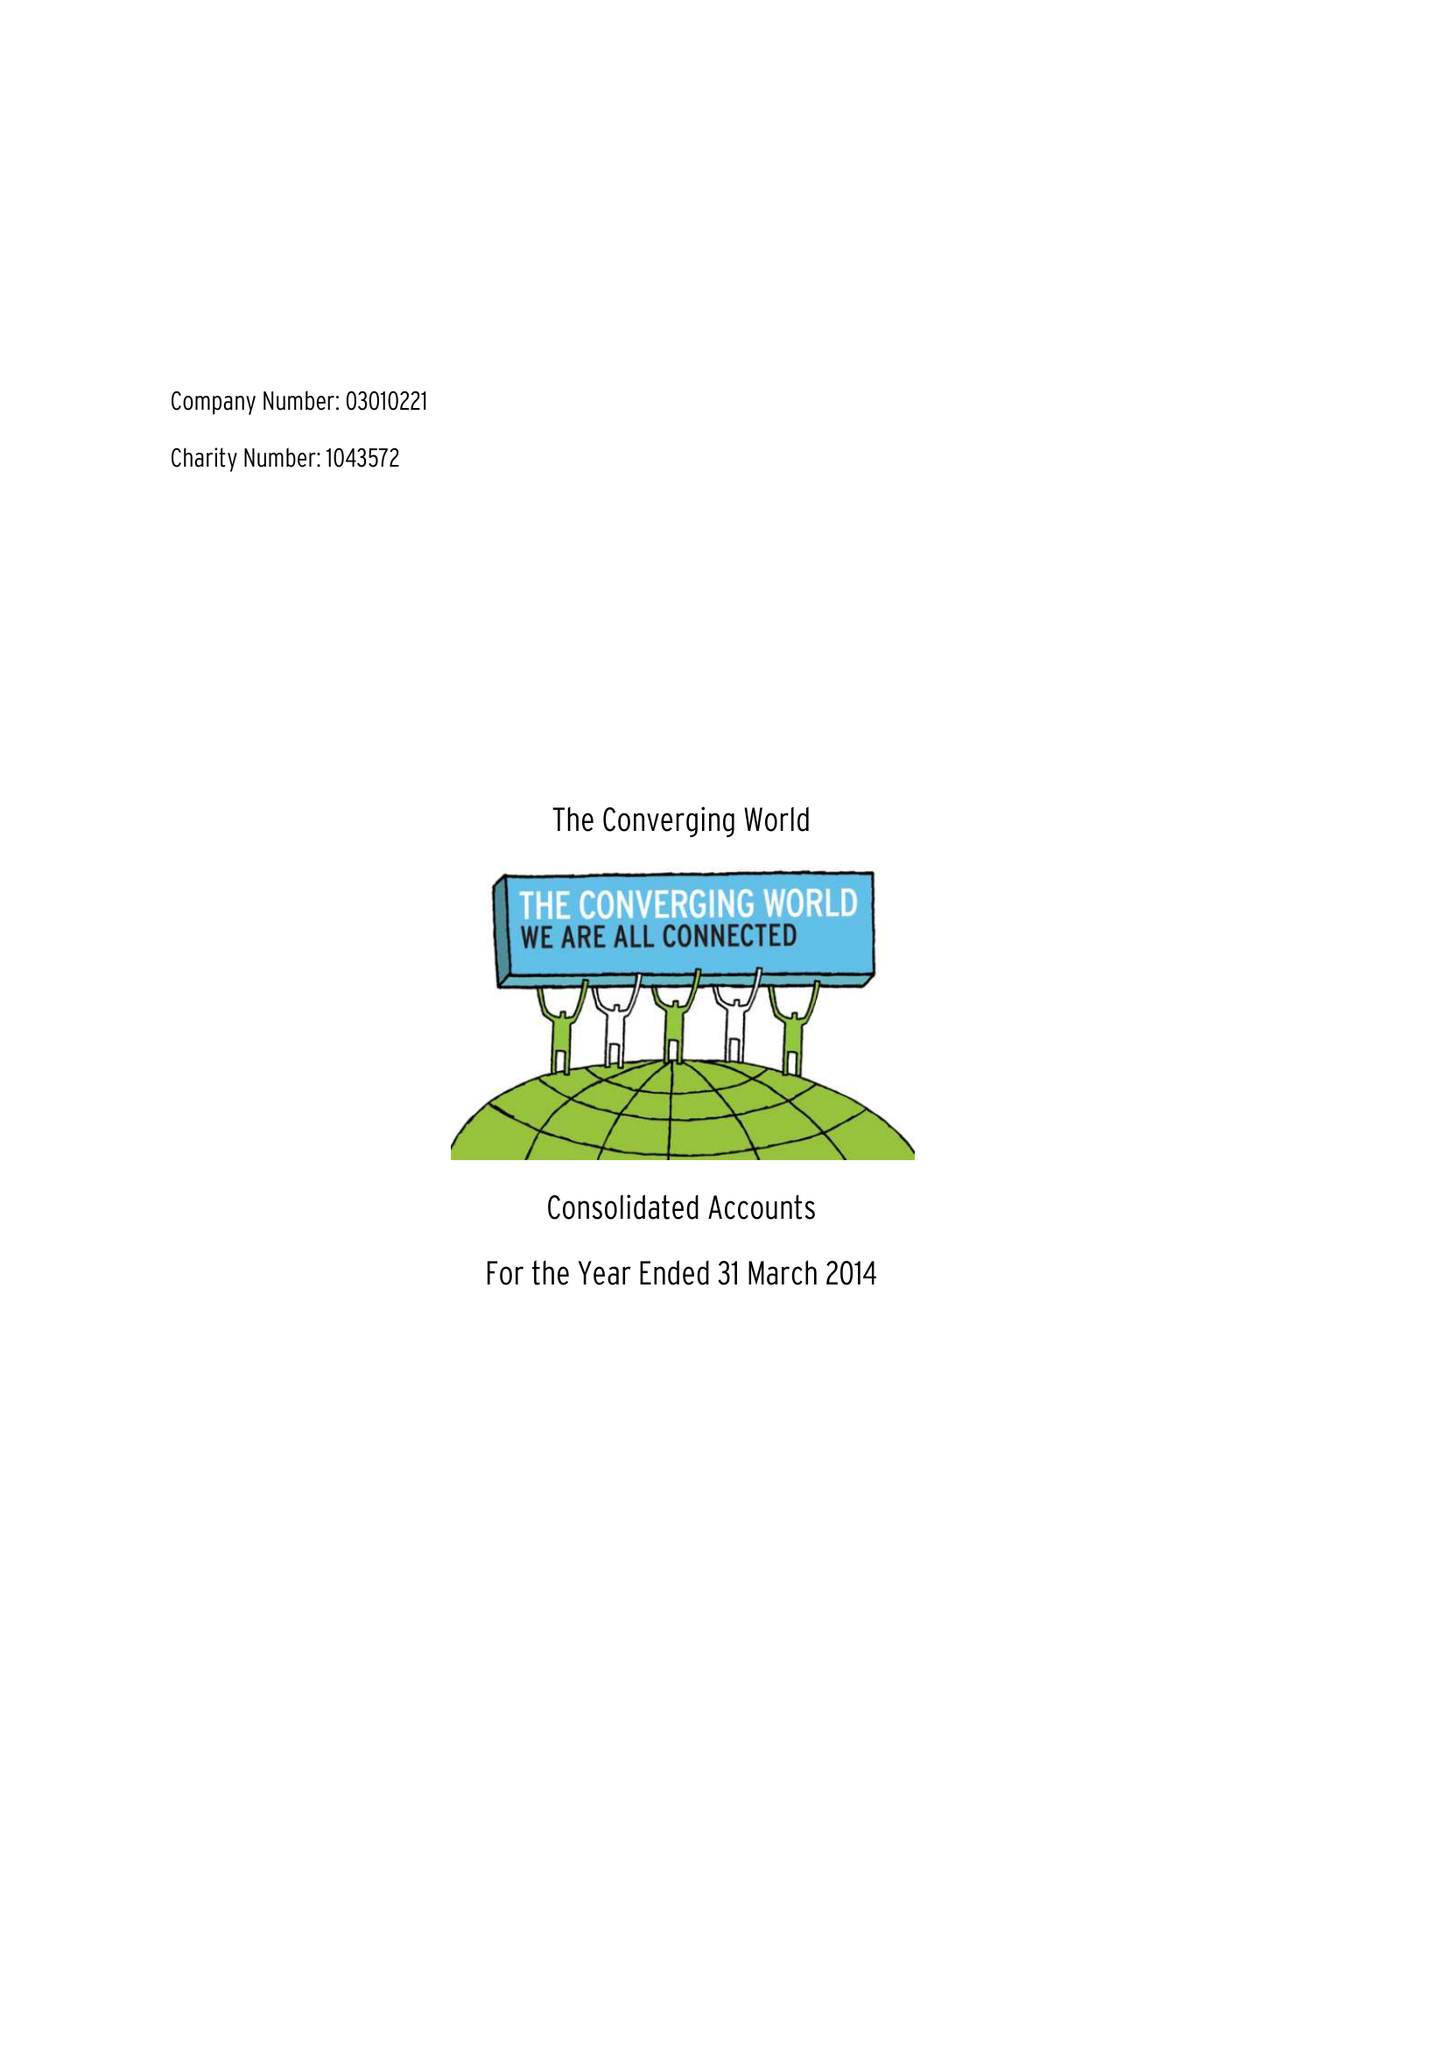What is the value for the report_date?
Answer the question using a single word or phrase. 2014-03-31 